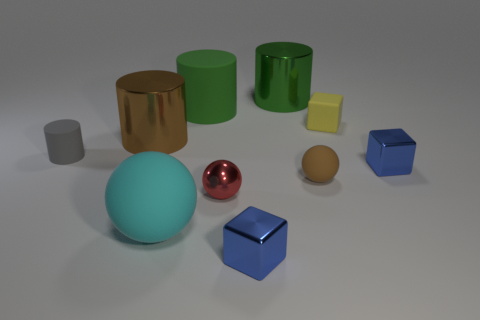Subtract all blocks. How many objects are left? 7 Subtract all tiny yellow matte blocks. Subtract all big matte blocks. How many objects are left? 9 Add 5 yellow matte objects. How many yellow matte objects are left? 6 Add 2 yellow matte blocks. How many yellow matte blocks exist? 3 Subtract 1 brown cylinders. How many objects are left? 9 